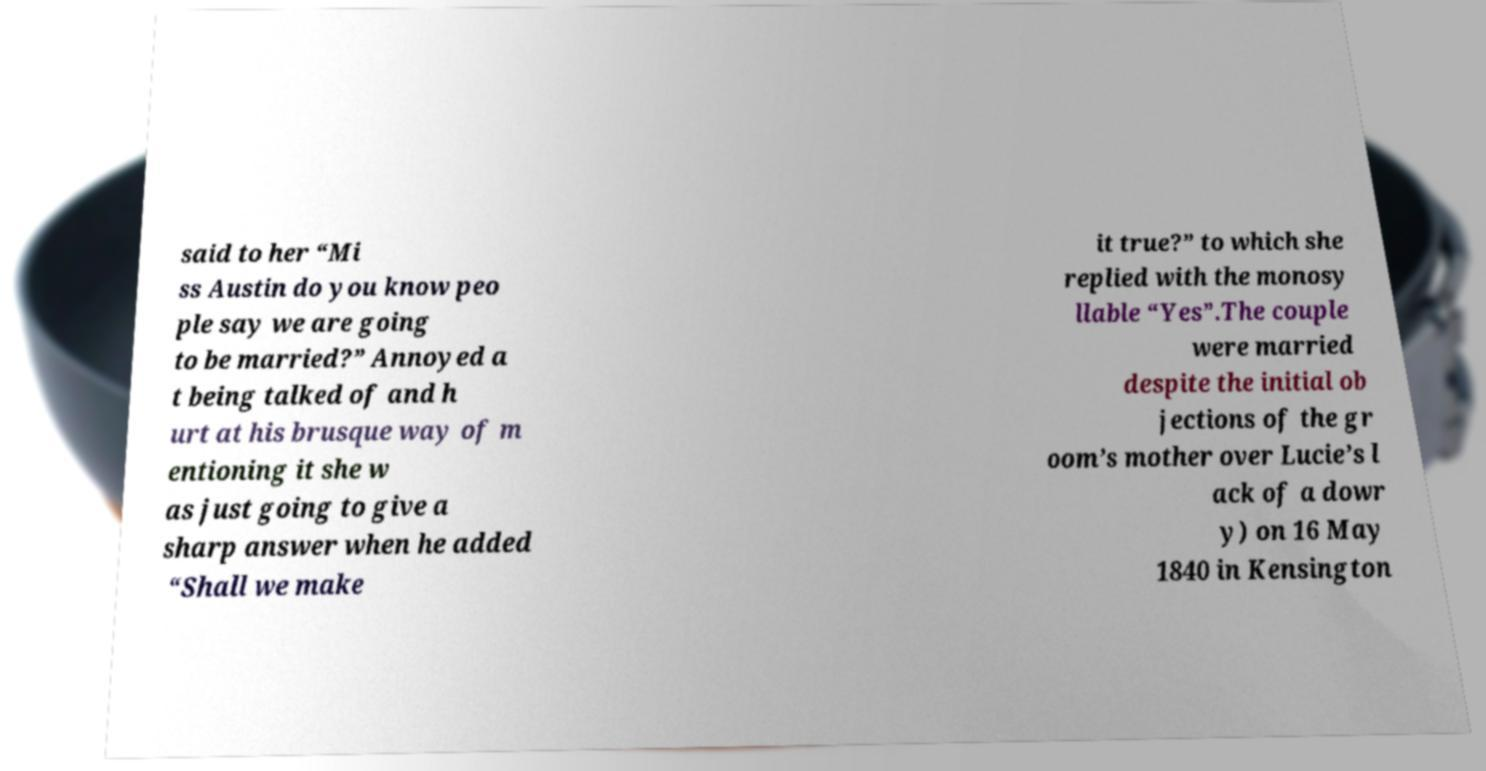Please read and relay the text visible in this image. What does it say? said to her “Mi ss Austin do you know peo ple say we are going to be married?” Annoyed a t being talked of and h urt at his brusque way of m entioning it she w as just going to give a sharp answer when he added “Shall we make it true?” to which she replied with the monosy llable “Yes”.The couple were married despite the initial ob jections of the gr oom’s mother over Lucie’s l ack of a dowr y) on 16 May 1840 in Kensington 